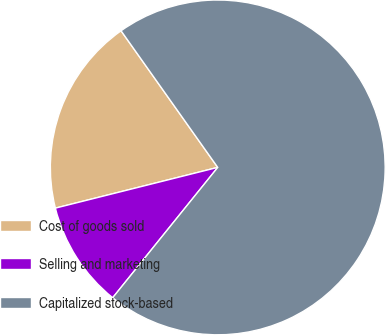<chart> <loc_0><loc_0><loc_500><loc_500><pie_chart><fcel>Cost of goods sold<fcel>Selling and marketing<fcel>Capitalized stock-based<nl><fcel>19.11%<fcel>10.29%<fcel>70.6%<nl></chart> 